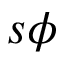Convert formula to latex. <formula><loc_0><loc_0><loc_500><loc_500>s \phi</formula> 